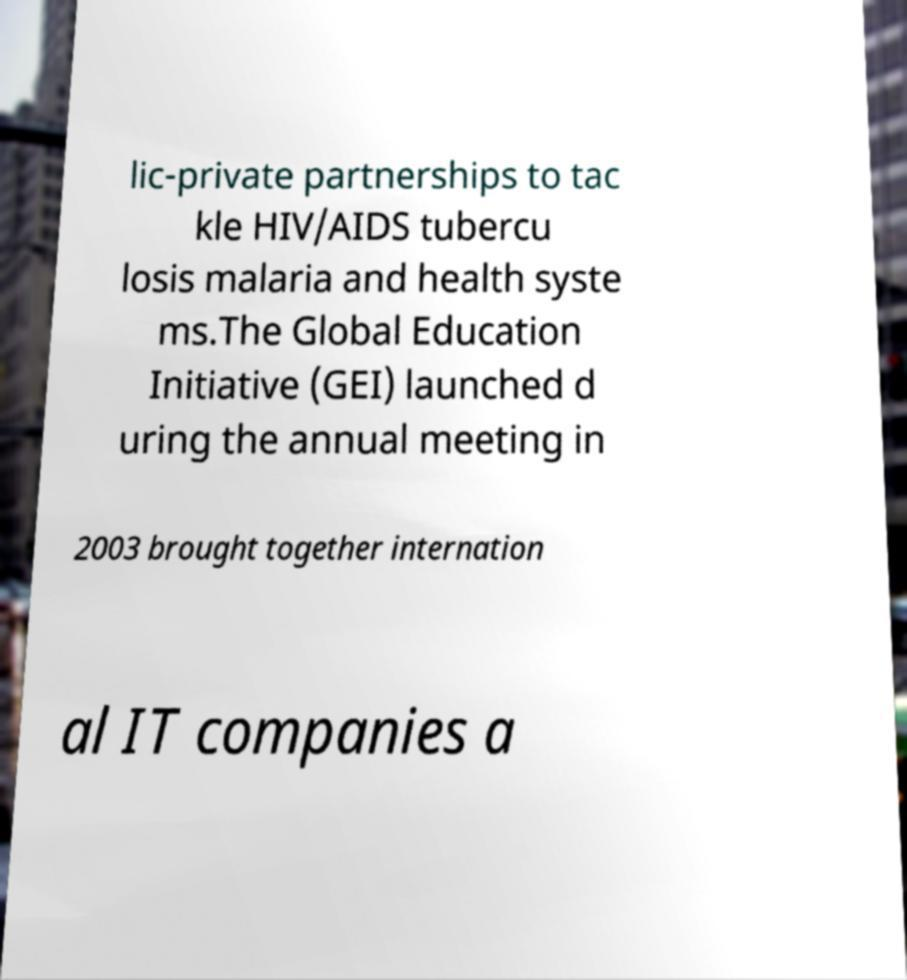Can you read and provide the text displayed in the image?This photo seems to have some interesting text. Can you extract and type it out for me? lic-private partnerships to tac kle HIV/AIDS tubercu losis malaria and health syste ms.The Global Education Initiative (GEI) launched d uring the annual meeting in 2003 brought together internation al IT companies a 